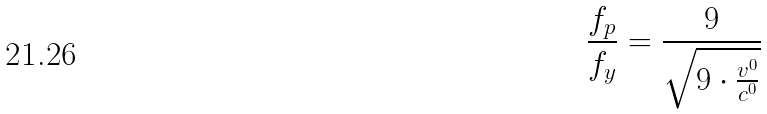<formula> <loc_0><loc_0><loc_500><loc_500>\frac { f _ { p } } { f _ { y } } = \frac { 9 } { \sqrt { 9 \cdot \frac { v ^ { 0 } } { c ^ { 0 } } } }</formula> 